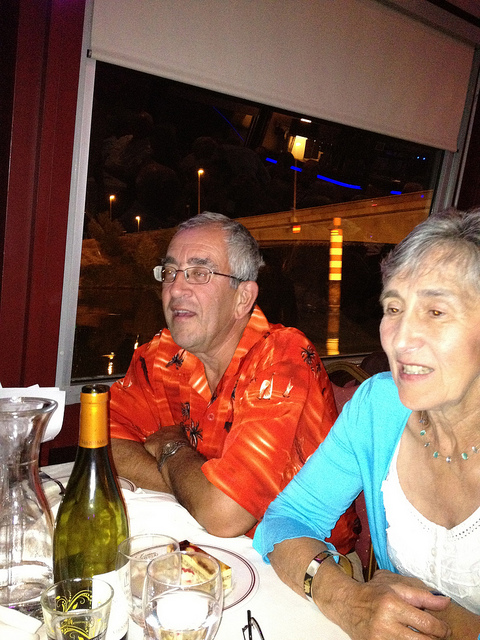Please provide a short description for this region: [0.29, 0.32, 0.66, 0.85]. An older man wearing an orange Hawaiian shirt, sitting at a dinner table. 